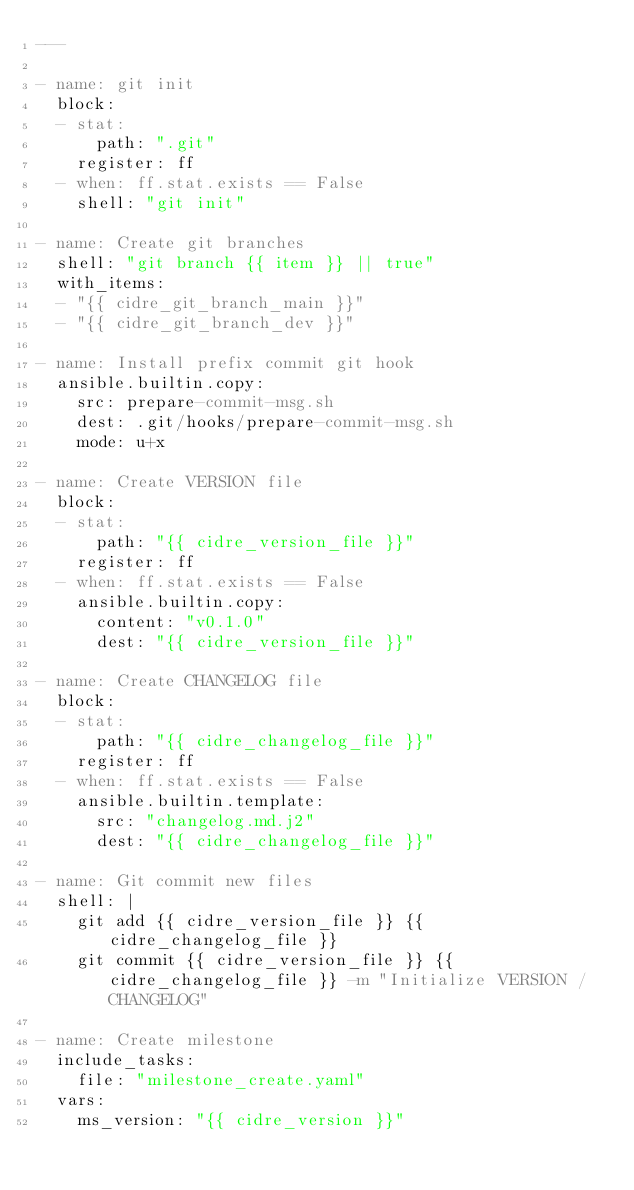Convert code to text. <code><loc_0><loc_0><loc_500><loc_500><_YAML_>---

- name: git init
  block:
  - stat:
      path: ".git"
    register: ff
  - when: ff.stat.exists == False
    shell: "git init"

- name: Create git branches
  shell: "git branch {{ item }} || true"
  with_items:
  - "{{ cidre_git_branch_main }}"
  - "{{ cidre_git_branch_dev }}"

- name: Install prefix commit git hook
  ansible.builtin.copy:
    src: prepare-commit-msg.sh
    dest: .git/hooks/prepare-commit-msg.sh
    mode: u+x

- name: Create VERSION file
  block:
  - stat:
      path: "{{ cidre_version_file }}"
    register: ff
  - when: ff.stat.exists == False
    ansible.builtin.copy:
      content: "v0.1.0"
      dest: "{{ cidre_version_file }}"

- name: Create CHANGELOG file
  block:
  - stat:
      path: "{{ cidre_changelog_file }}"
    register: ff
  - when: ff.stat.exists == False
    ansible.builtin.template:
      src: "changelog.md.j2"
      dest: "{{ cidre_changelog_file }}"

- name: Git commit new files
  shell: |
    git add {{ cidre_version_file }} {{ cidre_changelog_file }}
    git commit {{ cidre_version_file }} {{ cidre_changelog_file }} -m "Initialize VERSION / CHANGELOG"

- name: Create milestone
  include_tasks:
    file: "milestone_create.yaml"
  vars:
    ms_version: "{{ cidre_version }}"
</code> 